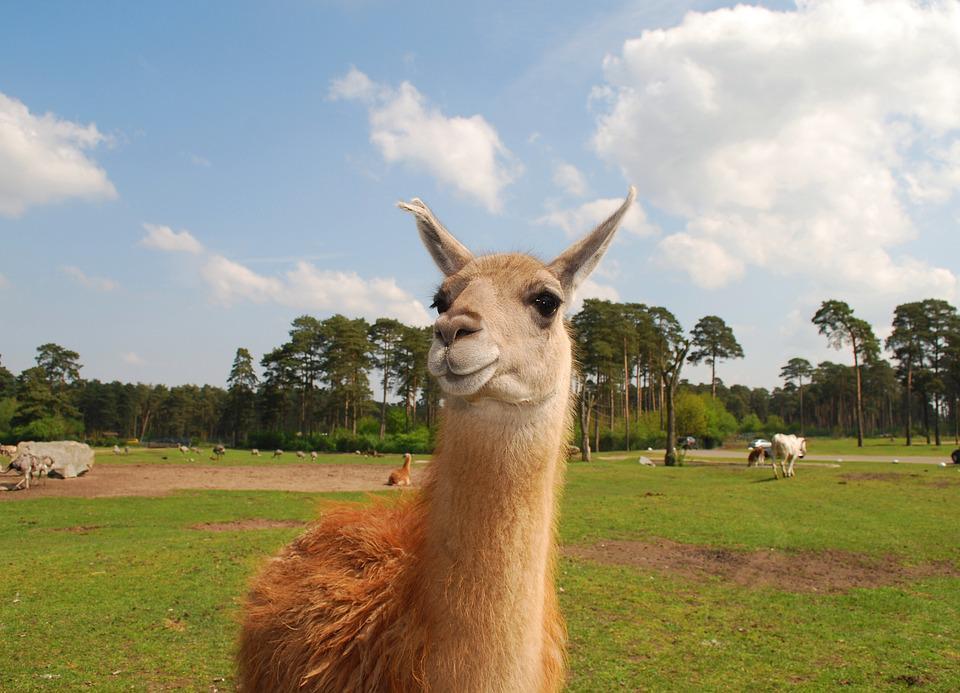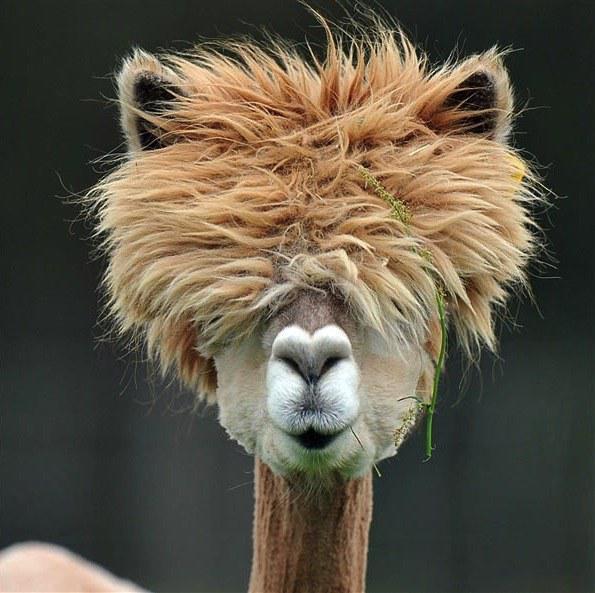The first image is the image on the left, the second image is the image on the right. For the images shown, is this caption "In the image on the right, the llama's eyes are obscured." true? Answer yes or no. Yes. The first image is the image on the left, the second image is the image on the right. For the images shown, is this caption "Each image features one llama in the foreground, and the righthand llama looks at the camera with a toothy smile." true? Answer yes or no. No. 